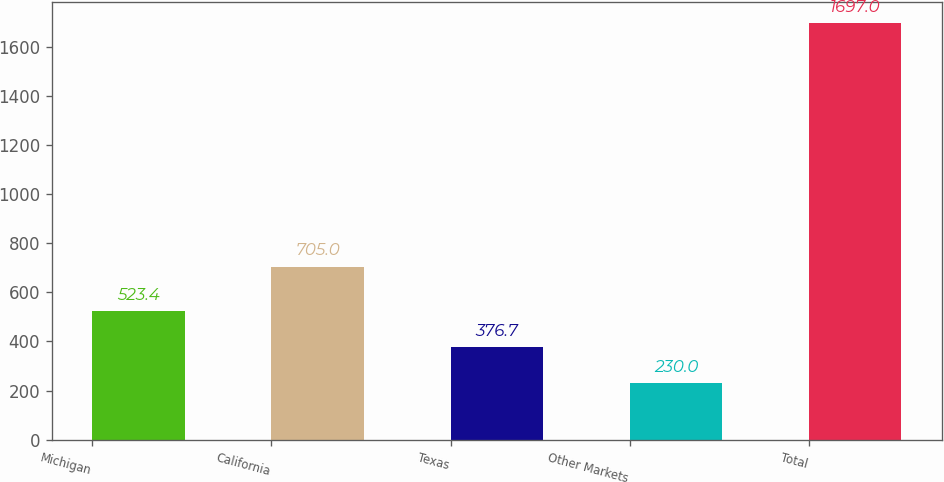Convert chart. <chart><loc_0><loc_0><loc_500><loc_500><bar_chart><fcel>Michigan<fcel>California<fcel>Texas<fcel>Other Markets<fcel>Total<nl><fcel>523.4<fcel>705<fcel>376.7<fcel>230<fcel>1697<nl></chart> 